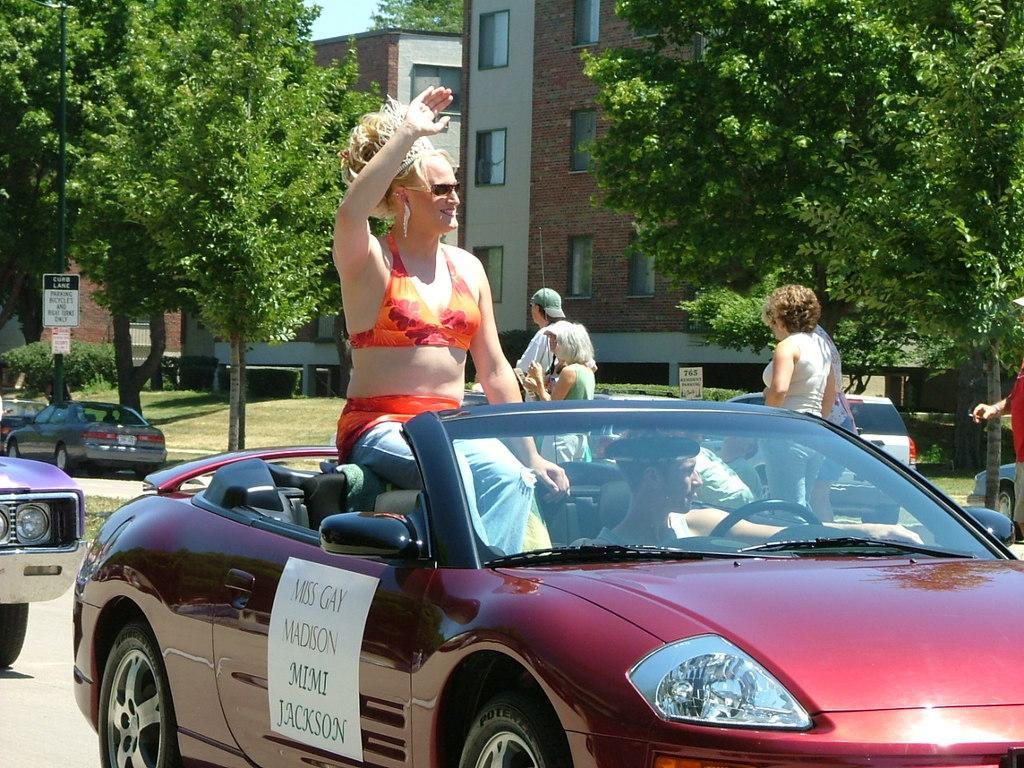How would you summarize this image in a sentence or two? This picture is clicked outside the city. Here, we see a car which is moving on road. In car, we see women in orange dress is sitting on top of the car. Behind that, we see two cars moving on the road and on right corner of picture, we see people walking on road. Behind them, we see trees and buildings. 